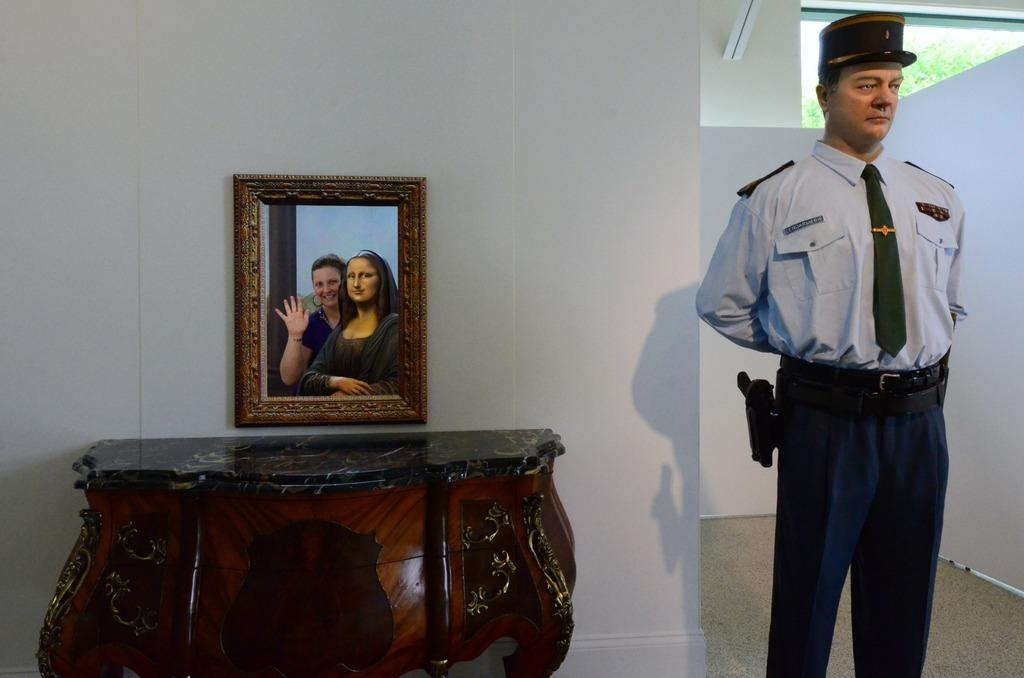What can you describe the object on the right side of the image? There is a mannequin on the right side of the image. What is located in the center of the image? There is a table in the center of the image. What is placed on the table? There is a photo frame on the table. What can be seen in the background of the image? There is a wall and a window in the background of the image. What can be seen in the background of the image? There is a wall and a window in the background of the image. What type of light is being used to illuminate the mannequin in the image? There is no specific light source mentioned or visible in the image, so it is not possible to determine the type of light being used. What type of apparel is the mannequin wearing in the image? The image does not show the mannequin wearing any apparel, as it is likely a display mannequin without clothing. What appliance is present on the table in the image? There is no appliance mentioned or visible on the table in the image; only a photo frame is present. 